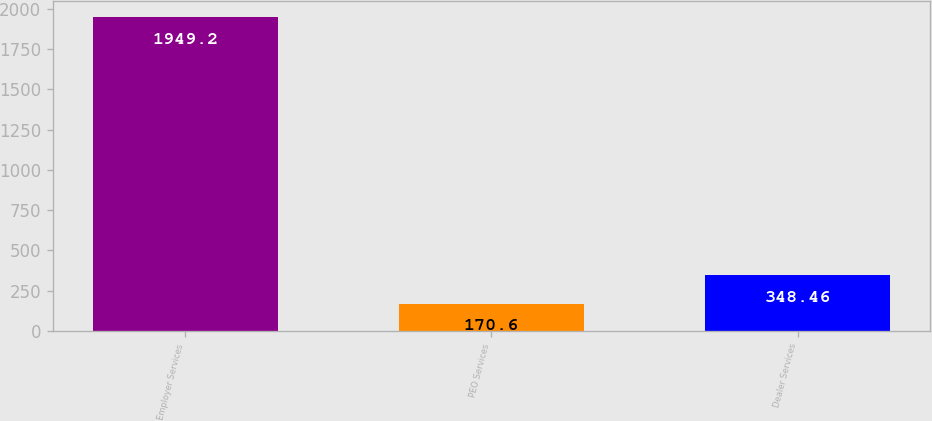<chart> <loc_0><loc_0><loc_500><loc_500><bar_chart><fcel>Employer Services<fcel>PEO Services<fcel>Dealer Services<nl><fcel>1949.2<fcel>170.6<fcel>348.46<nl></chart> 